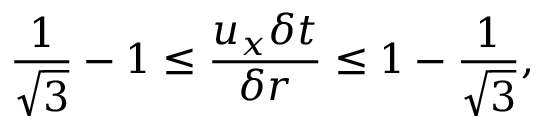<formula> <loc_0><loc_0><loc_500><loc_500>\frac { 1 } { \sqrt { 3 } } - 1 \leq \frac { u _ { x } \delta t } { \delta r } \leq 1 - \frac { 1 } { \sqrt { 3 } } ,</formula> 